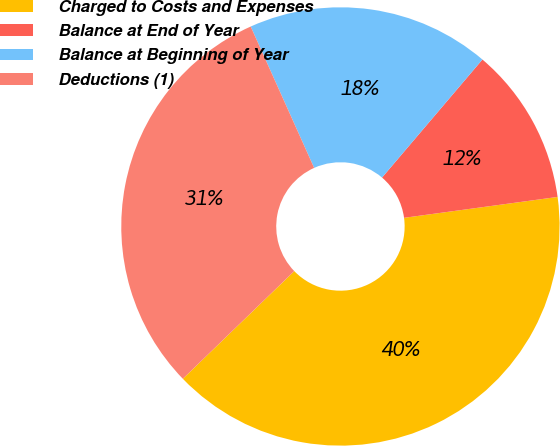Convert chart to OTSL. <chart><loc_0><loc_0><loc_500><loc_500><pie_chart><fcel>Charged to Costs and Expenses<fcel>Balance at End of Year<fcel>Balance at Beginning of Year<fcel>Deductions (1)<nl><fcel>39.92%<fcel>11.63%<fcel>17.93%<fcel>30.51%<nl></chart> 